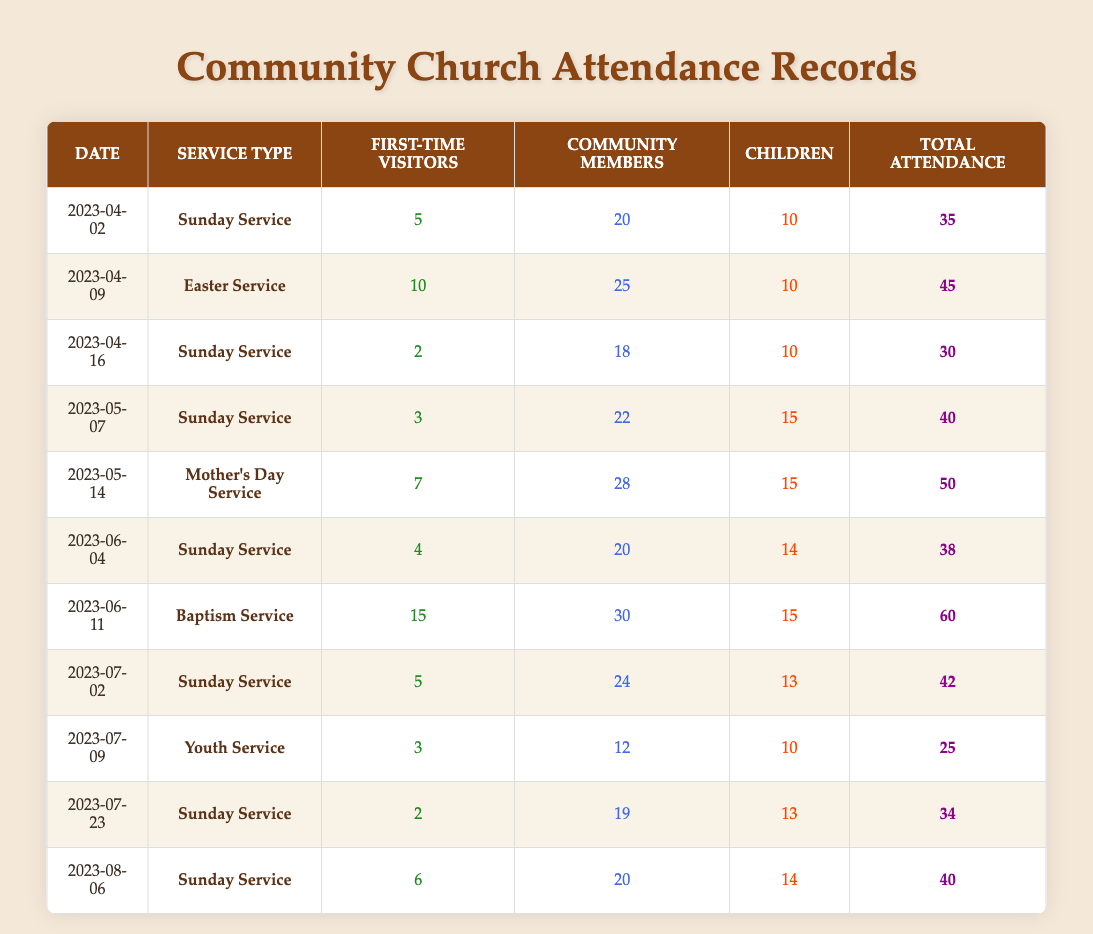What was the highest attendance at a service in the last six months? The highest attendance listed in the table is 60, which occurred on June 11 during the Baptism Service.
Answer: 60 What date had the most first-time visitors? The date with the most first-time visitors is June 11, where there were 15 first-time visitors at the Baptism Service.
Answer: June 11 Was there any Sunday Service that had fewer than 35 attendees? Yes, on April 16, the Sunday Service had an attendance of 30, which is fewer than 35.
Answer: Yes What is the average attendance for all Sunday Services? The Sunday Services have attendances of 35, 30, 40, 38, 42, and 34. To find the average, sum them up: (35 + 30 + 40 + 38 + 42 + 34) = 219. There are 6 Sunday Services, so the average is 219/6 = 36.5.
Answer: 36.5 How many community members attended the Mother’s Day Service? The attendance of community members on May 14 during the Mother’s Day Service is 28.
Answer: 28 What was the total attendance for all services in July? There were two services in July with attendances of 42 on July 2 and 25 on July 9. Adding these gives a total of 42 + 25 = 67.
Answer: 67 Did any service have more children than community members in attendance? Yes, on May 14 during the Mother's Day Service, there were 15 children and 28 community members, which shows fewer children than community members. However, the original statement does indicate that the children accepted in other services varied. After checking all rows, no service instance meets the criteria clearly as children's attendance was usually consistently lower than or equal to the community.
Answer: No What is the difference in total attendance between the Baptism Service and the Youth Service? The attendance for the Baptism Service on June 11 was 60, while the Youth Service on July 9 had an attendance of 25. Therefore, the difference in attendance is 60 - 25 = 35.
Answer: 35 How many first-time visitors were there at the Easter Service? The Easter Service on April 9 had 10 first-time visitors according to the data provided.
Answer: 10 